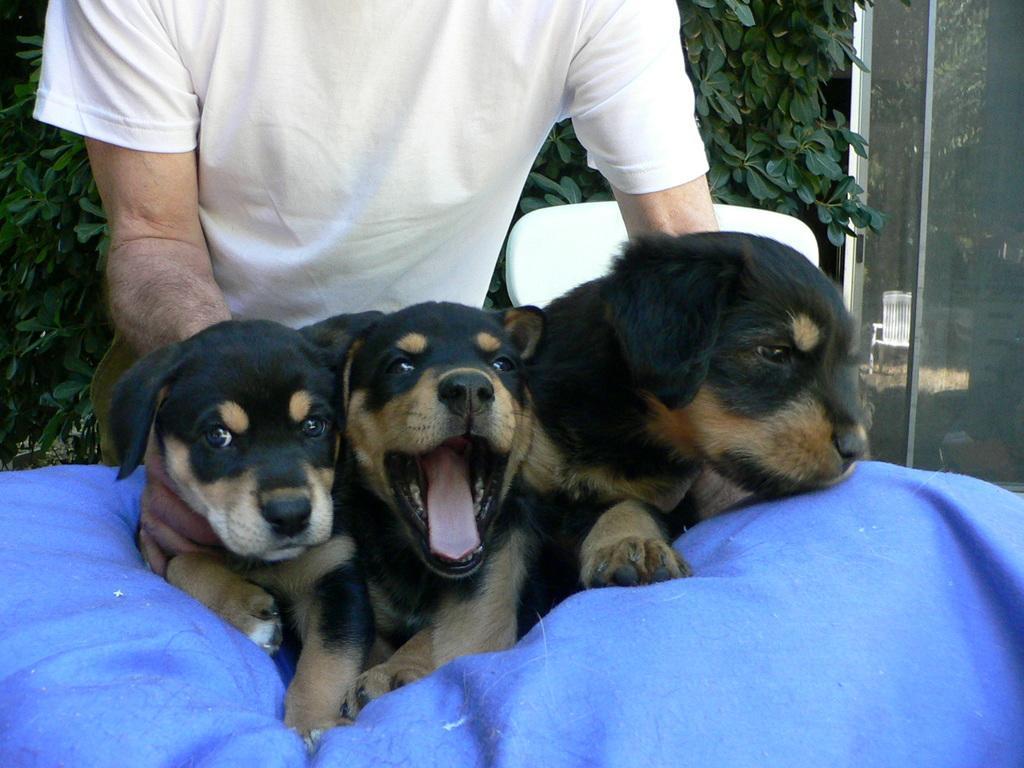In one or two sentences, can you explain what this image depicts? In this image we can see some person holding the three dogs which are on the blue color bean bag. In the background we can see the plant and also the glass window through which we can see a chair. 